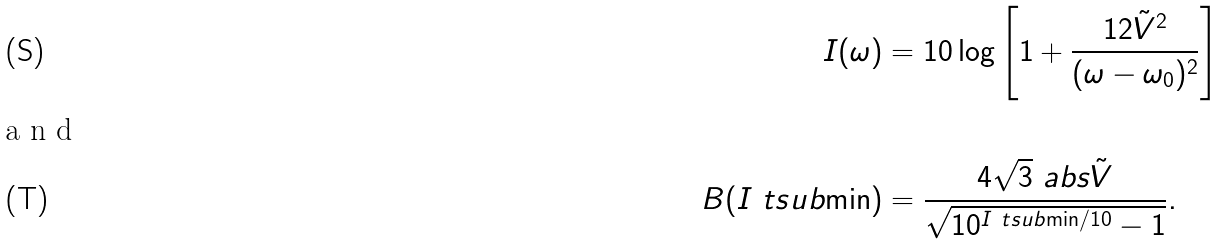<formula> <loc_0><loc_0><loc_500><loc_500>I ( \omega ) & = 1 0 \log \left [ 1 + \frac { 1 2 \tilde { V } ^ { 2 } } { ( \omega - \omega _ { 0 } ) ^ { 2 } } \right ] \\ \intertext { a n d } B ( I \ t s u b { \min } ) & = \frac { 4 \sqrt { 3 } \ a b s { \tilde { V } } } { \sqrt { 1 0 ^ { I \ t s u b { \min } / 1 0 } - 1 } } .</formula> 